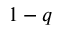<formula> <loc_0><loc_0><loc_500><loc_500>1 - q</formula> 